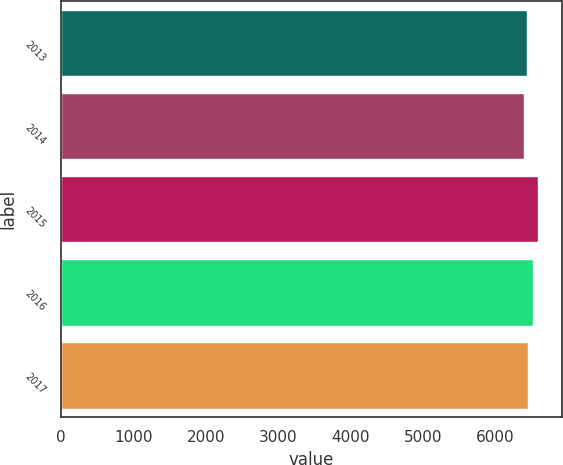<chart> <loc_0><loc_0><loc_500><loc_500><bar_chart><fcel>2013<fcel>2014<fcel>2015<fcel>2016<fcel>2017<nl><fcel>6430<fcel>6387<fcel>6587<fcel>6512<fcel>6450<nl></chart> 